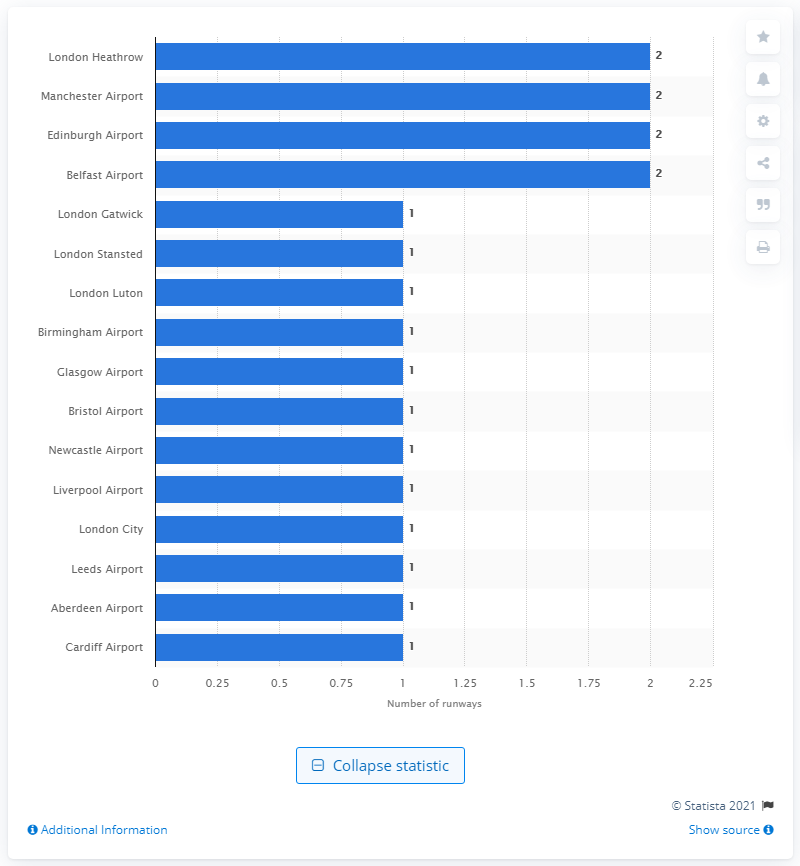Mention a couple of crucial points in this snapshot. London Heathrow, Manchester Airport, and Edinburgh Airport all had two runways. 